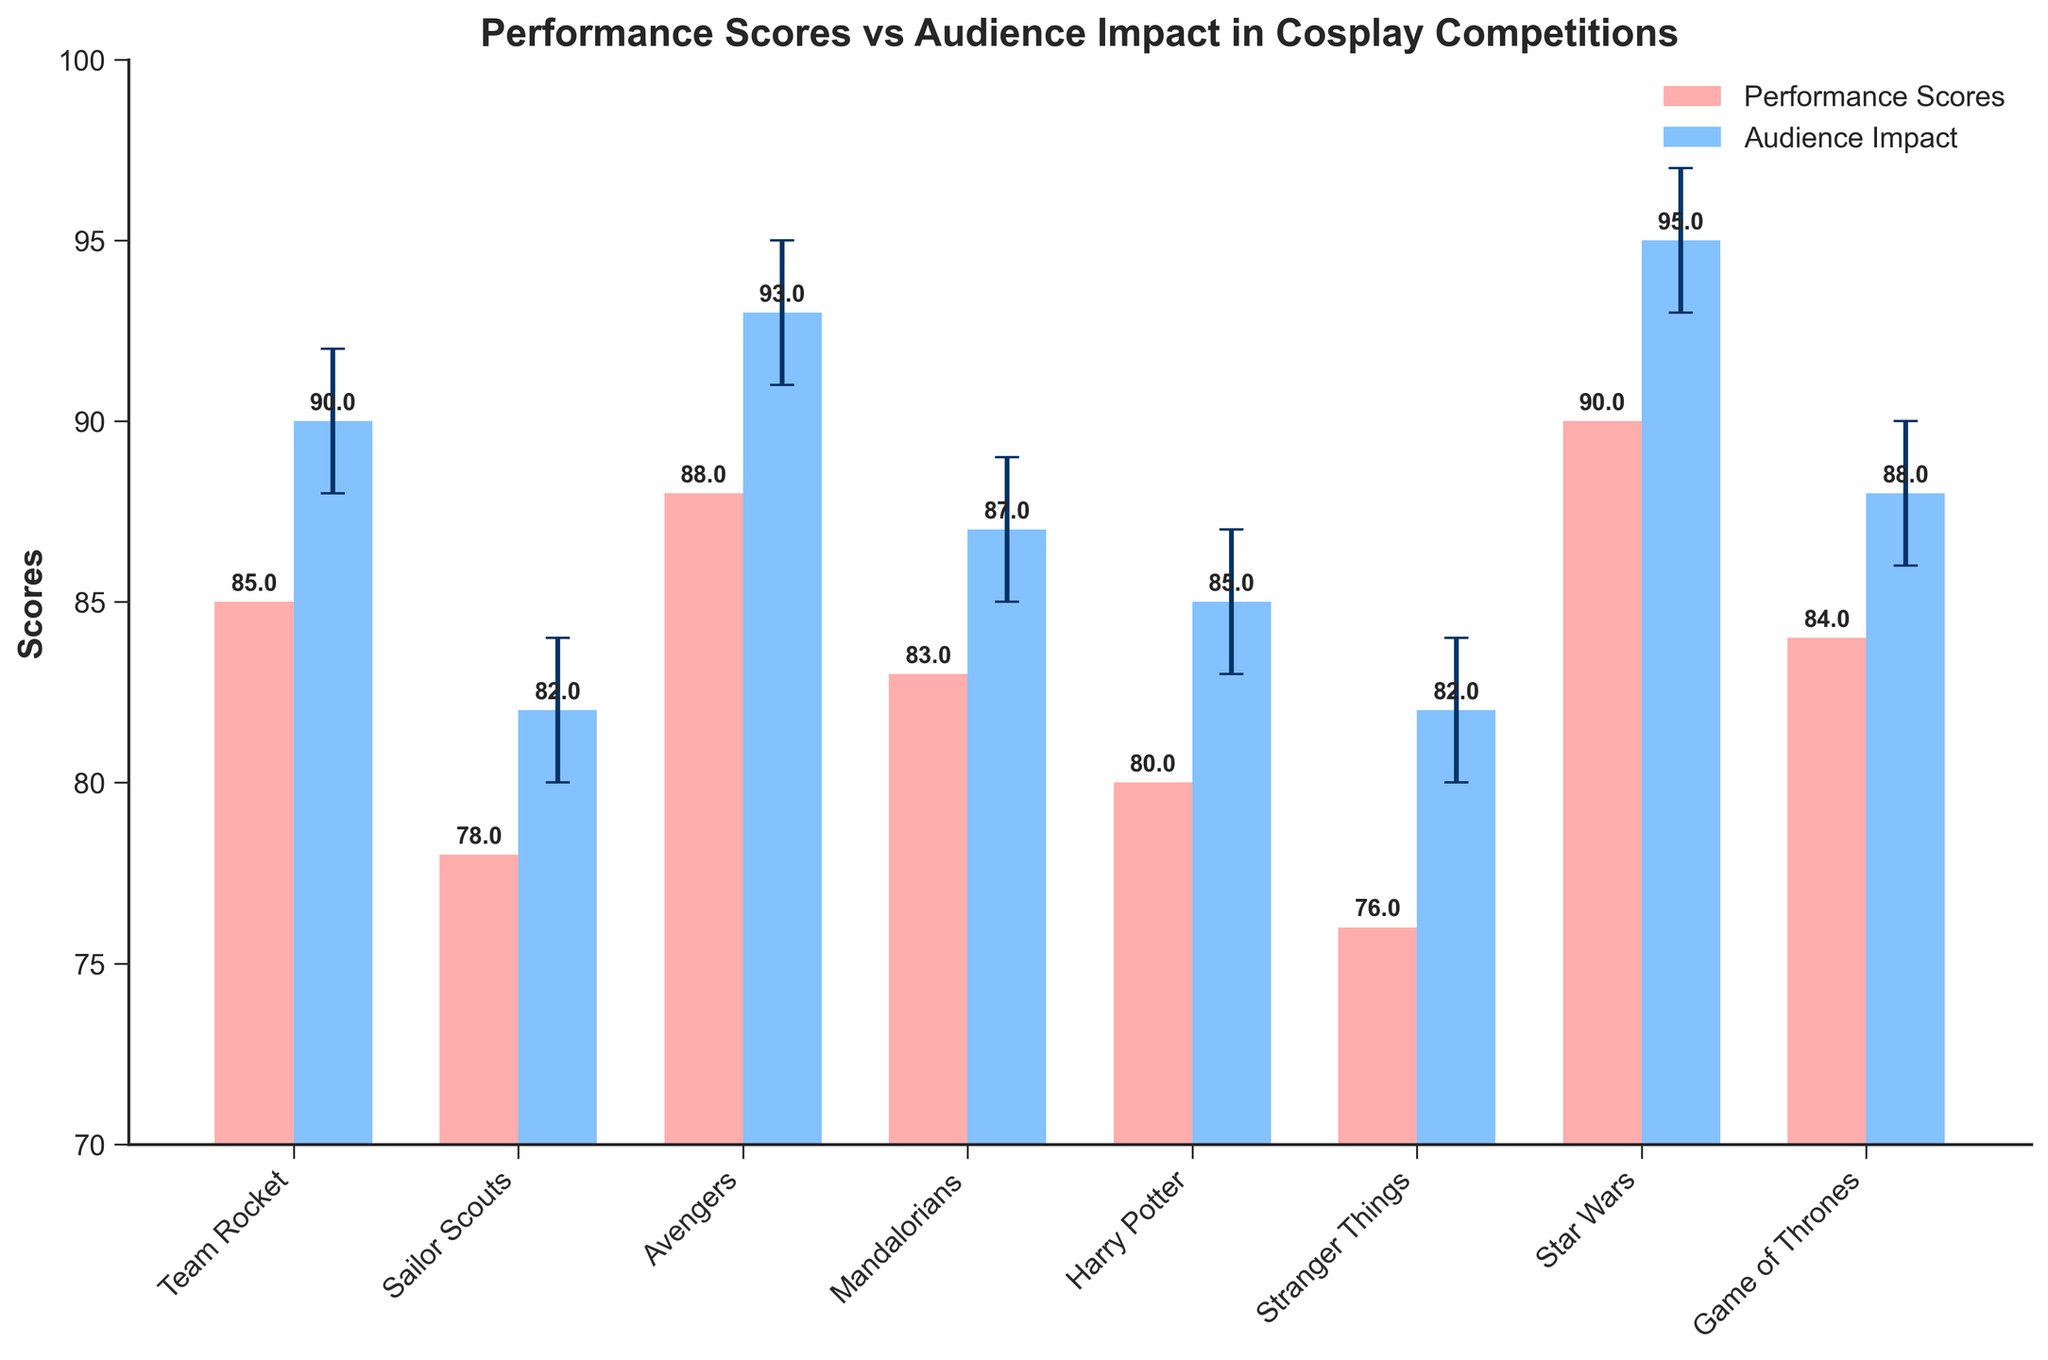What is the title of the figure? The title of the figure is usually shown at the top of the chart. Reading from the top of the figure, the title is "Performance Scores vs Audience Impact in Cosplay Competitions."
Answer: Performance Scores vs Audience Impact in Cosplay Competitions What is the Performance Score Mean of Team Rocket? The Performance Score Mean can be seen on the bars representing the 'Performance Scores' category. The bar for Team Rocket shows a height corresponding to a score of 85.
Answer: 85 Which cosplay group has the highest Audience Impact Mean? By examining the heights of the bars under 'Audience Impact', the one representing Star Wars is the tallest, indicating it has the highest Audience Impact Mean of 95.
Answer: Star Wars What is the difference between the Audience Impact Mean and the Performance Score Mean for the Avengers? To find the difference for the Avengers, subtract the Performance Scores Mean (88) from the Audience Impact Mean (93). The result is 93 - 88 = 5.
Answer: 5 How many cosplay groups have an Audience Impact Mean above 90? From the figure, the cosplay groups with Audience Impact Mean above 90 are Team Rocket, Avengers, Star Wars, and Game of Thrones. There are 4 such groups.
Answer: 4 Which cosplay group has the smallest confidence interval? The size of the confidence interval can be determined by the length of the error bars. The group with the smallest interval is Game of Thrones, with confidence intervals from 86 to 90, a difference of 90 - 86 = 4.
Answer: Game of Thrones What is the average Audience Impact Mean across all the cosplay groups? To calculate the average, sum all the Audience Impact Means and divide by the number of groups: (90 + 82 + 93 + 87 + 85 + 82 + 95 + 88) / 8 = 702 / 8 = 87.75.
Answer: 87.75 Compare the Performance Scores Mean and Audience Impact Mean for the Mandalorians. Are they equal? The Performance Scores Mean for the Mandalorians is 83, while their Audience Impact Mean is 87. These values are not equal.
Answer: No Which cosplay group has the greatest discrepancy between the Performance Score Mean and its Confidence Interval Upper Bound? To find the group with the greatest discrepancy, subtract the Performance Score Mean from its Confidence Interval Upper Bound for each group and look for the maximum value: (Team Rocket: 92 - 85 = 7, Sailor Scouts: 84 - 78 = 6, Avengers: 95 - 88 = 7, Mandalorians: 89 - 83 = 6, Harry Potter: 87 - 80 = 7, Stranger Things: 84 - 76 = 8, Star Wars: 97 - 90 = 7, Game of Thrones: 90 - 84 = 6). Stranger Things has the greatest discrepancy of 8.
Answer: Stranger Things 